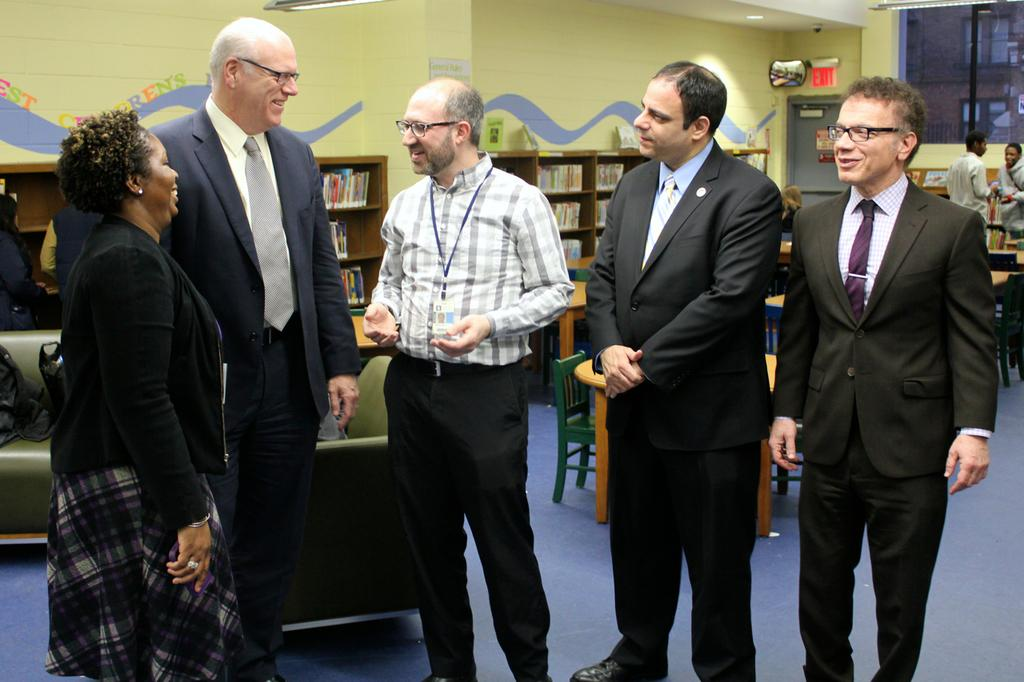What can be seen in the image in terms of people? There are people standing in the image. What type of furniture is present in the image? There are chairs and couches in the image. Are there any storage units visible in the image? Yes, there are bookshelves in the image. What can be said about the wall in the image? The wall is painted. How does the steam escape from the attention-grabbing route in the image? There is no steam or route present in the image; it features people, chairs, couches, bookshelves, and a painted wall. 